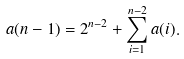<formula> <loc_0><loc_0><loc_500><loc_500>a ( n - 1 ) = 2 ^ { n - 2 } + \sum _ { i = 1 } ^ { n - 2 } a ( i ) .</formula> 